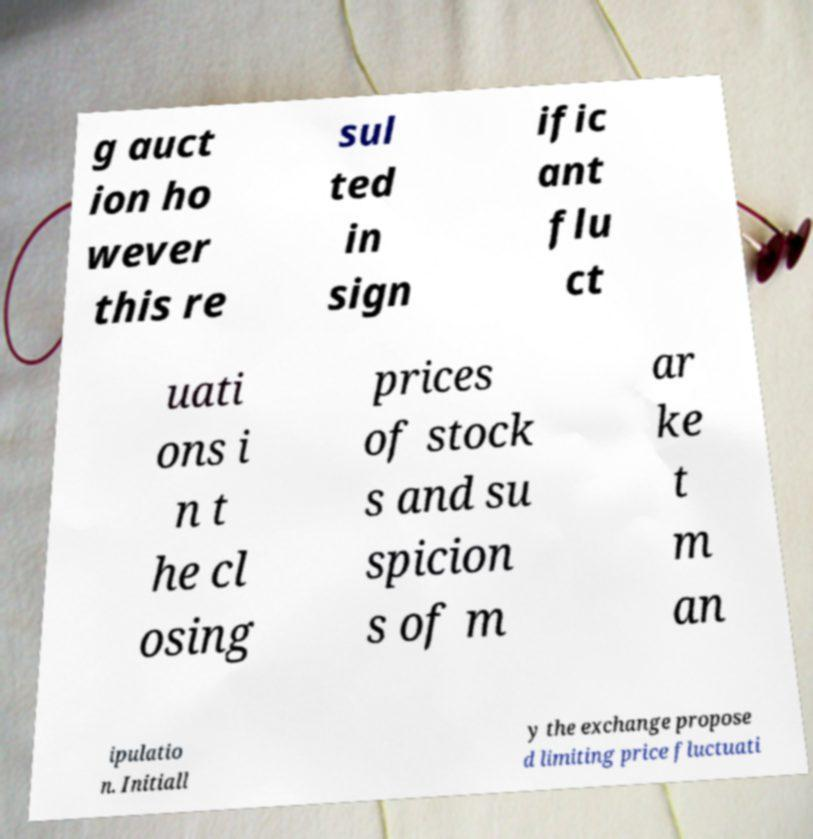Can you read and provide the text displayed in the image?This photo seems to have some interesting text. Can you extract and type it out for me? g auct ion ho wever this re sul ted in sign ific ant flu ct uati ons i n t he cl osing prices of stock s and su spicion s of m ar ke t m an ipulatio n. Initiall y the exchange propose d limiting price fluctuati 